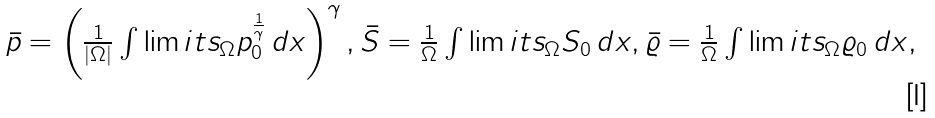<formula> <loc_0><loc_0><loc_500><loc_500>\begin{array} { l l } \bar { p } = \left ( \frac { 1 } { | \Omega | } \int \lim i t s _ { \Omega } p _ { 0 } ^ { \frac { 1 } { \gamma } } \, d x \right ) ^ { \gamma } , \bar { S } = \frac { 1 } { \Omega } \int \lim i t s _ { \Omega } S _ { 0 } \, d x , \bar { \varrho } = \frac { 1 } { \Omega } \int \lim i t s _ { \Omega } \varrho _ { 0 } \, d x , \end{array}</formula> 